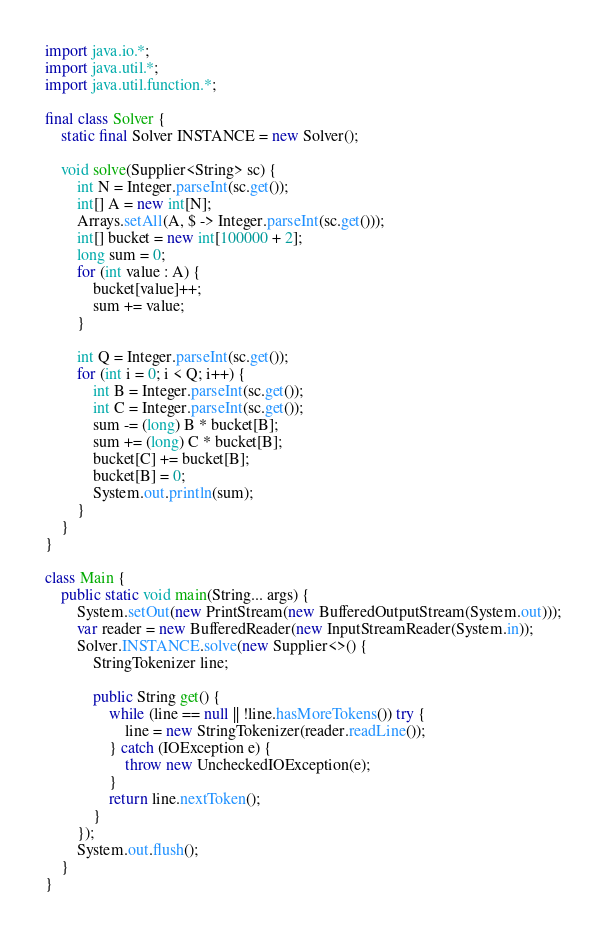Convert code to text. <code><loc_0><loc_0><loc_500><loc_500><_Java_>import java.io.*;
import java.util.*;
import java.util.function.*;

final class Solver {
	static final Solver INSTANCE = new Solver();

	void solve(Supplier<String> sc) {
		int N = Integer.parseInt(sc.get());
		int[] A = new int[N];
		Arrays.setAll(A, $ -> Integer.parseInt(sc.get()));
		int[] bucket = new int[100000 + 2];
		long sum = 0;
		for (int value : A) {
			bucket[value]++;
			sum += value;
		}

		int Q = Integer.parseInt(sc.get());
		for (int i = 0; i < Q; i++) {
			int B = Integer.parseInt(sc.get());
			int C = Integer.parseInt(sc.get());
			sum -= (long) B * bucket[B];
			sum += (long) C * bucket[B];
			bucket[C] += bucket[B];
			bucket[B] = 0;
			System.out.println(sum);
		}
	}
}

class Main {
	public static void main(String... args) {
		System.setOut(new PrintStream(new BufferedOutputStream(System.out)));
		var reader = new BufferedReader(new InputStreamReader(System.in));
		Solver.INSTANCE.solve(new Supplier<>() {
			StringTokenizer line;

			public String get() {
				while (line == null || !line.hasMoreTokens()) try {
					line = new StringTokenizer(reader.readLine());
				} catch (IOException e) {
					throw new UncheckedIOException(e);
				}
				return line.nextToken();
			}
		});
		System.out.flush();
	}
}</code> 